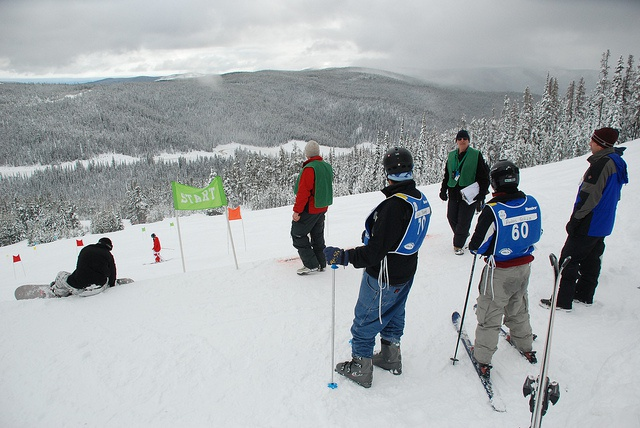Describe the objects in this image and their specific colors. I can see people in darkgray, black, blue, gray, and navy tones, people in darkgray, gray, black, blue, and darkblue tones, people in darkgray, black, navy, gray, and darkblue tones, people in darkgray, black, maroon, and darkgreen tones, and people in darkgray, black, darkgreen, teal, and lightgray tones in this image. 